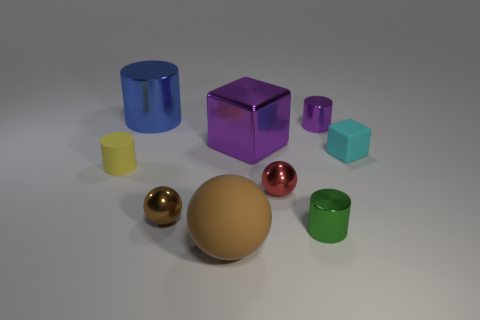Are there any other things that are the same color as the big matte sphere?
Offer a terse response. Yes. What is the shape of the small thing that is the same color as the large block?
Offer a very short reply. Cylinder. Is the shape of the purple object on the right side of the big purple object the same as the large thing that is behind the big purple shiny thing?
Offer a very short reply. Yes. Are there any yellow cylinders that are to the right of the cube left of the small green thing?
Your answer should be very brief. No. Is there a tiny green matte sphere?
Give a very brief answer. No. How many green metal things have the same size as the metal block?
Give a very brief answer. 0. How many things are in front of the yellow rubber thing and to the left of the green cylinder?
Keep it short and to the point. 3. There is a purple shiny thing to the right of the green cylinder; is it the same size as the large rubber sphere?
Give a very brief answer. No. Are there any metallic cylinders that have the same color as the large metal cube?
Offer a terse response. Yes. The block that is made of the same material as the yellow cylinder is what size?
Your response must be concise. Small. 